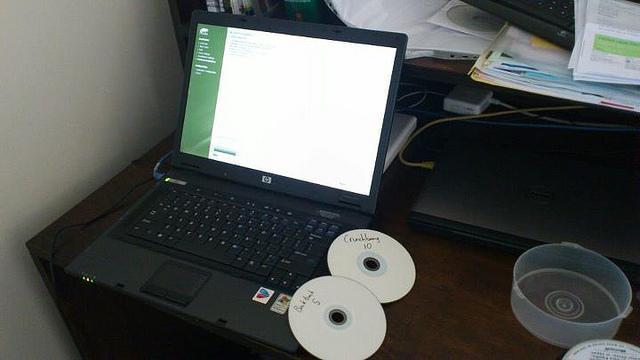How many people are standing on the side waiting to surf?
Give a very brief answer. 0. 